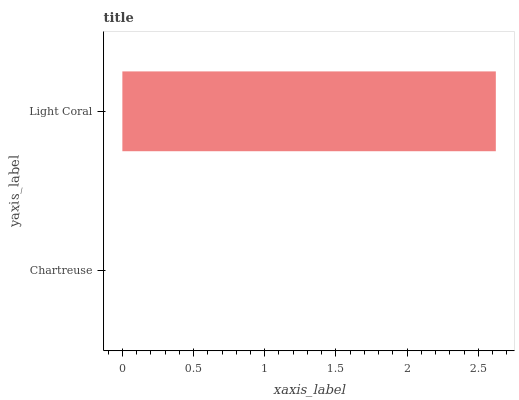Is Chartreuse the minimum?
Answer yes or no. Yes. Is Light Coral the maximum?
Answer yes or no. Yes. Is Light Coral the minimum?
Answer yes or no. No. Is Light Coral greater than Chartreuse?
Answer yes or no. Yes. Is Chartreuse less than Light Coral?
Answer yes or no. Yes. Is Chartreuse greater than Light Coral?
Answer yes or no. No. Is Light Coral less than Chartreuse?
Answer yes or no. No. Is Light Coral the high median?
Answer yes or no. Yes. Is Chartreuse the low median?
Answer yes or no. Yes. Is Chartreuse the high median?
Answer yes or no. No. Is Light Coral the low median?
Answer yes or no. No. 